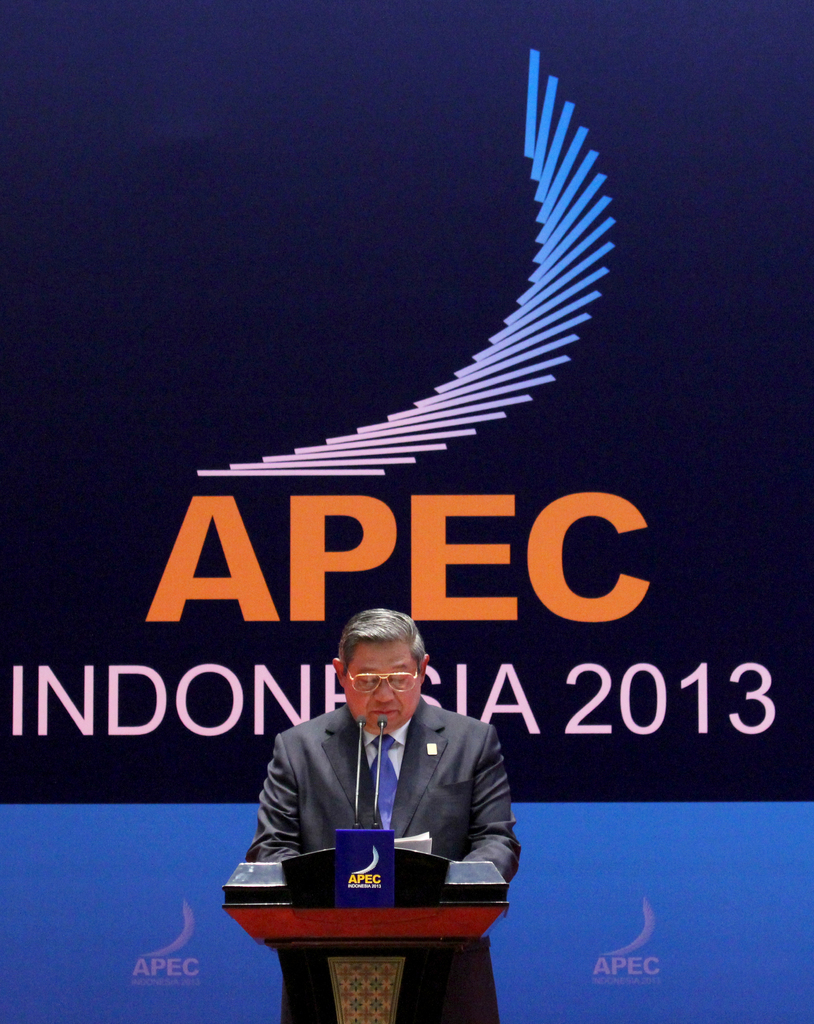Explain the significance of the APEC conference in 2013, particularly in Indonesia. The 2013 APEC conference in Indonesia played a crucial role in enhancing economic ties among Asia-Pacific nations. Hosting it underscored Indonesia's position as a growing economic force in the region. It provided a platform for discussing sustainable economic growth, trade liberalization, and investment in the region, fostering a collective move towards development and integration in a post-global financial crisis era. 